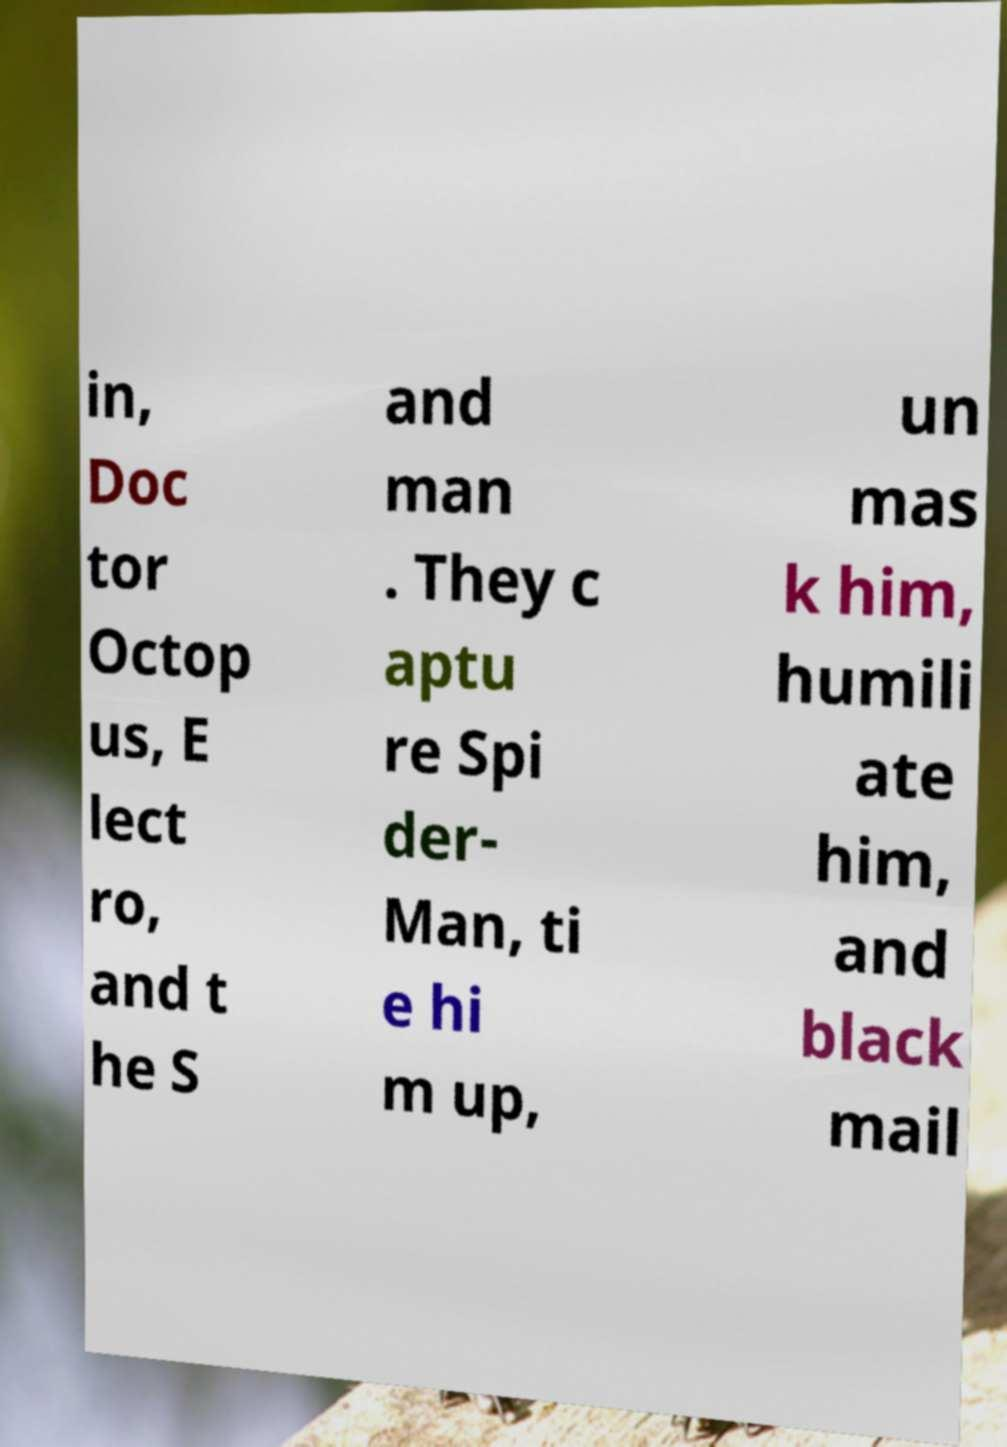Can you accurately transcribe the text from the provided image for me? in, Doc tor Octop us, E lect ro, and t he S and man . They c aptu re Spi der- Man, ti e hi m up, un mas k him, humili ate him, and black mail 